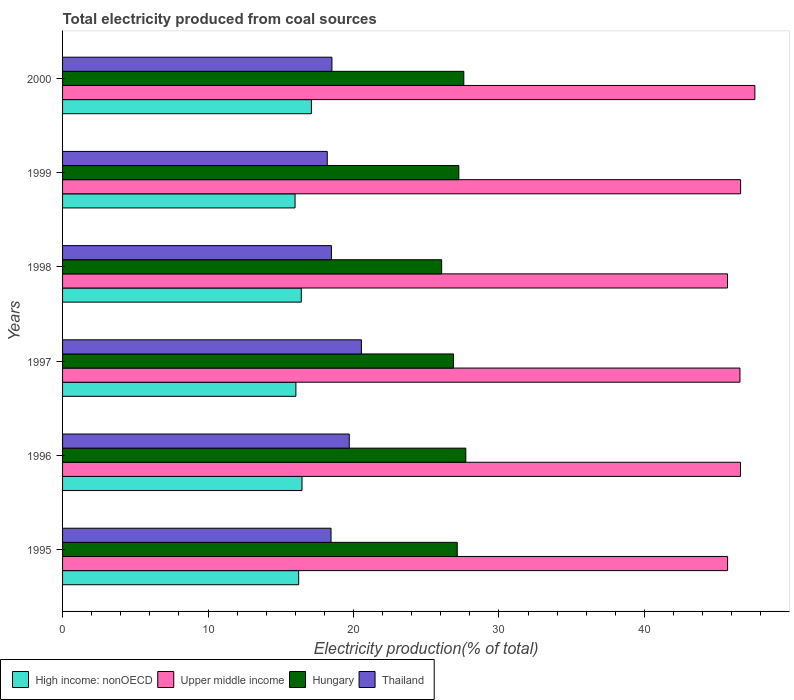How many different coloured bars are there?
Your answer should be very brief. 4. Are the number of bars per tick equal to the number of legend labels?
Offer a very short reply. Yes. How many bars are there on the 5th tick from the top?
Make the answer very short. 4. How many bars are there on the 1st tick from the bottom?
Keep it short and to the point. 4. What is the label of the 4th group of bars from the top?
Offer a terse response. 1997. What is the total electricity produced in Upper middle income in 1997?
Offer a very short reply. 46.57. Across all years, what is the maximum total electricity produced in Hungary?
Provide a succinct answer. 27.72. Across all years, what is the minimum total electricity produced in Thailand?
Your response must be concise. 18.2. In which year was the total electricity produced in Upper middle income maximum?
Ensure brevity in your answer.  2000. What is the total total electricity produced in Upper middle income in the graph?
Offer a terse response. 278.8. What is the difference between the total electricity produced in Thailand in 1996 and that in 1998?
Provide a succinct answer. 1.23. What is the difference between the total electricity produced in Thailand in 1996 and the total electricity produced in Hungary in 1995?
Ensure brevity in your answer.  -7.42. What is the average total electricity produced in Hungary per year?
Make the answer very short. 27.1. In the year 1999, what is the difference between the total electricity produced in Hungary and total electricity produced in Thailand?
Make the answer very short. 9.04. In how many years, is the total electricity produced in Upper middle income greater than 26 %?
Provide a succinct answer. 6. What is the ratio of the total electricity produced in Thailand in 1998 to that in 1999?
Keep it short and to the point. 1.02. Is the total electricity produced in Thailand in 1995 less than that in 2000?
Offer a terse response. Yes. Is the difference between the total electricity produced in Hungary in 1995 and 1998 greater than the difference between the total electricity produced in Thailand in 1995 and 1998?
Keep it short and to the point. Yes. What is the difference between the highest and the second highest total electricity produced in Thailand?
Offer a very short reply. 0.83. What is the difference between the highest and the lowest total electricity produced in High income: nonOECD?
Ensure brevity in your answer.  1.12. Is the sum of the total electricity produced in Hungary in 1997 and 1999 greater than the maximum total electricity produced in Thailand across all years?
Your response must be concise. Yes. Is it the case that in every year, the sum of the total electricity produced in High income: nonOECD and total electricity produced in Upper middle income is greater than the sum of total electricity produced in Hungary and total electricity produced in Thailand?
Your answer should be compact. Yes. What does the 1st bar from the top in 1999 represents?
Ensure brevity in your answer.  Thailand. What does the 4th bar from the bottom in 1997 represents?
Provide a succinct answer. Thailand. How many bars are there?
Offer a very short reply. 24. How many years are there in the graph?
Provide a succinct answer. 6. How many legend labels are there?
Your response must be concise. 4. How are the legend labels stacked?
Your answer should be very brief. Horizontal. What is the title of the graph?
Provide a short and direct response. Total electricity produced from coal sources. Does "Ireland" appear as one of the legend labels in the graph?
Provide a succinct answer. No. What is the Electricity production(% of total) in High income: nonOECD in 1995?
Your answer should be very brief. 16.23. What is the Electricity production(% of total) of Upper middle income in 1995?
Make the answer very short. 45.72. What is the Electricity production(% of total) of Hungary in 1995?
Your answer should be compact. 27.13. What is the Electricity production(% of total) in Thailand in 1995?
Ensure brevity in your answer.  18.46. What is the Electricity production(% of total) in High income: nonOECD in 1996?
Provide a succinct answer. 16.46. What is the Electricity production(% of total) of Upper middle income in 1996?
Give a very brief answer. 46.6. What is the Electricity production(% of total) of Hungary in 1996?
Give a very brief answer. 27.72. What is the Electricity production(% of total) of Thailand in 1996?
Make the answer very short. 19.71. What is the Electricity production(% of total) in High income: nonOECD in 1997?
Offer a very short reply. 16.04. What is the Electricity production(% of total) in Upper middle income in 1997?
Provide a succinct answer. 46.57. What is the Electricity production(% of total) in Hungary in 1997?
Your answer should be very brief. 26.87. What is the Electricity production(% of total) in Thailand in 1997?
Ensure brevity in your answer.  20.54. What is the Electricity production(% of total) in High income: nonOECD in 1998?
Provide a succinct answer. 16.41. What is the Electricity production(% of total) of Upper middle income in 1998?
Your response must be concise. 45.71. What is the Electricity production(% of total) in Hungary in 1998?
Provide a short and direct response. 26.06. What is the Electricity production(% of total) of Thailand in 1998?
Provide a short and direct response. 18.48. What is the Electricity production(% of total) in High income: nonOECD in 1999?
Make the answer very short. 15.98. What is the Electricity production(% of total) in Upper middle income in 1999?
Provide a succinct answer. 46.61. What is the Electricity production(% of total) of Hungary in 1999?
Provide a short and direct response. 27.24. What is the Electricity production(% of total) in Thailand in 1999?
Provide a succinct answer. 18.2. What is the Electricity production(% of total) in High income: nonOECD in 2000?
Keep it short and to the point. 17.11. What is the Electricity production(% of total) in Upper middle income in 2000?
Make the answer very short. 47.59. What is the Electricity production(% of total) in Hungary in 2000?
Ensure brevity in your answer.  27.58. What is the Electricity production(% of total) of Thailand in 2000?
Your answer should be very brief. 18.52. Across all years, what is the maximum Electricity production(% of total) of High income: nonOECD?
Provide a short and direct response. 17.11. Across all years, what is the maximum Electricity production(% of total) in Upper middle income?
Offer a terse response. 47.59. Across all years, what is the maximum Electricity production(% of total) in Hungary?
Provide a succinct answer. 27.72. Across all years, what is the maximum Electricity production(% of total) of Thailand?
Provide a succinct answer. 20.54. Across all years, what is the minimum Electricity production(% of total) in High income: nonOECD?
Ensure brevity in your answer.  15.98. Across all years, what is the minimum Electricity production(% of total) of Upper middle income?
Give a very brief answer. 45.71. Across all years, what is the minimum Electricity production(% of total) of Hungary?
Offer a terse response. 26.06. Across all years, what is the minimum Electricity production(% of total) in Thailand?
Your answer should be compact. 18.2. What is the total Electricity production(% of total) of High income: nonOECD in the graph?
Offer a very short reply. 98.23. What is the total Electricity production(% of total) in Upper middle income in the graph?
Keep it short and to the point. 278.8. What is the total Electricity production(% of total) in Hungary in the graph?
Offer a terse response. 162.61. What is the total Electricity production(% of total) in Thailand in the graph?
Make the answer very short. 113.91. What is the difference between the Electricity production(% of total) in High income: nonOECD in 1995 and that in 1996?
Your answer should be compact. -0.23. What is the difference between the Electricity production(% of total) in Upper middle income in 1995 and that in 1996?
Offer a very short reply. -0.89. What is the difference between the Electricity production(% of total) of Hungary in 1995 and that in 1996?
Your response must be concise. -0.59. What is the difference between the Electricity production(% of total) in Thailand in 1995 and that in 1996?
Ensure brevity in your answer.  -1.25. What is the difference between the Electricity production(% of total) in High income: nonOECD in 1995 and that in 1997?
Give a very brief answer. 0.19. What is the difference between the Electricity production(% of total) in Upper middle income in 1995 and that in 1997?
Provide a short and direct response. -0.85. What is the difference between the Electricity production(% of total) of Hungary in 1995 and that in 1997?
Provide a succinct answer. 0.26. What is the difference between the Electricity production(% of total) in Thailand in 1995 and that in 1997?
Your answer should be compact. -2.09. What is the difference between the Electricity production(% of total) of High income: nonOECD in 1995 and that in 1998?
Offer a very short reply. -0.18. What is the difference between the Electricity production(% of total) in Upper middle income in 1995 and that in 1998?
Offer a very short reply. 0.01. What is the difference between the Electricity production(% of total) of Hungary in 1995 and that in 1998?
Give a very brief answer. 1.07. What is the difference between the Electricity production(% of total) of Thailand in 1995 and that in 1998?
Offer a very short reply. -0.03. What is the difference between the Electricity production(% of total) in High income: nonOECD in 1995 and that in 1999?
Provide a short and direct response. 0.25. What is the difference between the Electricity production(% of total) of Upper middle income in 1995 and that in 1999?
Make the answer very short. -0.89. What is the difference between the Electricity production(% of total) of Hungary in 1995 and that in 1999?
Give a very brief answer. -0.11. What is the difference between the Electricity production(% of total) in Thailand in 1995 and that in 1999?
Provide a short and direct response. 0.26. What is the difference between the Electricity production(% of total) in High income: nonOECD in 1995 and that in 2000?
Provide a short and direct response. -0.87. What is the difference between the Electricity production(% of total) in Upper middle income in 1995 and that in 2000?
Your answer should be compact. -1.88. What is the difference between the Electricity production(% of total) in Hungary in 1995 and that in 2000?
Provide a succinct answer. -0.45. What is the difference between the Electricity production(% of total) in Thailand in 1995 and that in 2000?
Provide a short and direct response. -0.06. What is the difference between the Electricity production(% of total) in High income: nonOECD in 1996 and that in 1997?
Make the answer very short. 0.42. What is the difference between the Electricity production(% of total) in Upper middle income in 1996 and that in 1997?
Your answer should be very brief. 0.04. What is the difference between the Electricity production(% of total) of Hungary in 1996 and that in 1997?
Offer a terse response. 0.85. What is the difference between the Electricity production(% of total) of Thailand in 1996 and that in 1997?
Your answer should be very brief. -0.83. What is the difference between the Electricity production(% of total) in High income: nonOECD in 1996 and that in 1998?
Give a very brief answer. 0.05. What is the difference between the Electricity production(% of total) of Upper middle income in 1996 and that in 1998?
Offer a very short reply. 0.89. What is the difference between the Electricity production(% of total) in Hungary in 1996 and that in 1998?
Give a very brief answer. 1.66. What is the difference between the Electricity production(% of total) of Thailand in 1996 and that in 1998?
Give a very brief answer. 1.23. What is the difference between the Electricity production(% of total) of High income: nonOECD in 1996 and that in 1999?
Your answer should be very brief. 0.48. What is the difference between the Electricity production(% of total) in Upper middle income in 1996 and that in 1999?
Your answer should be compact. -0.01. What is the difference between the Electricity production(% of total) in Hungary in 1996 and that in 1999?
Keep it short and to the point. 0.48. What is the difference between the Electricity production(% of total) in Thailand in 1996 and that in 1999?
Make the answer very short. 1.51. What is the difference between the Electricity production(% of total) of High income: nonOECD in 1996 and that in 2000?
Offer a terse response. -0.65. What is the difference between the Electricity production(% of total) of Upper middle income in 1996 and that in 2000?
Give a very brief answer. -0.99. What is the difference between the Electricity production(% of total) of Hungary in 1996 and that in 2000?
Ensure brevity in your answer.  0.14. What is the difference between the Electricity production(% of total) of Thailand in 1996 and that in 2000?
Ensure brevity in your answer.  1.19. What is the difference between the Electricity production(% of total) of High income: nonOECD in 1997 and that in 1998?
Provide a succinct answer. -0.37. What is the difference between the Electricity production(% of total) in Upper middle income in 1997 and that in 1998?
Keep it short and to the point. 0.86. What is the difference between the Electricity production(% of total) of Hungary in 1997 and that in 1998?
Give a very brief answer. 0.81. What is the difference between the Electricity production(% of total) in Thailand in 1997 and that in 1998?
Provide a short and direct response. 2.06. What is the difference between the Electricity production(% of total) of High income: nonOECD in 1997 and that in 1999?
Your answer should be very brief. 0.06. What is the difference between the Electricity production(% of total) of Upper middle income in 1997 and that in 1999?
Offer a terse response. -0.05. What is the difference between the Electricity production(% of total) in Hungary in 1997 and that in 1999?
Provide a succinct answer. -0.37. What is the difference between the Electricity production(% of total) in Thailand in 1997 and that in 1999?
Your answer should be very brief. 2.35. What is the difference between the Electricity production(% of total) in High income: nonOECD in 1997 and that in 2000?
Offer a very short reply. -1.07. What is the difference between the Electricity production(% of total) in Upper middle income in 1997 and that in 2000?
Keep it short and to the point. -1.03. What is the difference between the Electricity production(% of total) in Hungary in 1997 and that in 2000?
Keep it short and to the point. -0.71. What is the difference between the Electricity production(% of total) in Thailand in 1997 and that in 2000?
Your answer should be very brief. 2.03. What is the difference between the Electricity production(% of total) of High income: nonOECD in 1998 and that in 1999?
Make the answer very short. 0.43. What is the difference between the Electricity production(% of total) in Upper middle income in 1998 and that in 1999?
Keep it short and to the point. -0.9. What is the difference between the Electricity production(% of total) of Hungary in 1998 and that in 1999?
Make the answer very short. -1.18. What is the difference between the Electricity production(% of total) in Thailand in 1998 and that in 1999?
Give a very brief answer. 0.29. What is the difference between the Electricity production(% of total) in High income: nonOECD in 1998 and that in 2000?
Offer a terse response. -0.69. What is the difference between the Electricity production(% of total) in Upper middle income in 1998 and that in 2000?
Your answer should be very brief. -1.88. What is the difference between the Electricity production(% of total) in Hungary in 1998 and that in 2000?
Provide a short and direct response. -1.52. What is the difference between the Electricity production(% of total) of Thailand in 1998 and that in 2000?
Your response must be concise. -0.04. What is the difference between the Electricity production(% of total) in High income: nonOECD in 1999 and that in 2000?
Make the answer very short. -1.12. What is the difference between the Electricity production(% of total) of Upper middle income in 1999 and that in 2000?
Provide a succinct answer. -0.98. What is the difference between the Electricity production(% of total) in Hungary in 1999 and that in 2000?
Keep it short and to the point. -0.34. What is the difference between the Electricity production(% of total) of Thailand in 1999 and that in 2000?
Offer a terse response. -0.32. What is the difference between the Electricity production(% of total) in High income: nonOECD in 1995 and the Electricity production(% of total) in Upper middle income in 1996?
Make the answer very short. -30.37. What is the difference between the Electricity production(% of total) of High income: nonOECD in 1995 and the Electricity production(% of total) of Hungary in 1996?
Offer a very short reply. -11.49. What is the difference between the Electricity production(% of total) of High income: nonOECD in 1995 and the Electricity production(% of total) of Thailand in 1996?
Your response must be concise. -3.48. What is the difference between the Electricity production(% of total) of Upper middle income in 1995 and the Electricity production(% of total) of Hungary in 1996?
Ensure brevity in your answer.  18. What is the difference between the Electricity production(% of total) in Upper middle income in 1995 and the Electricity production(% of total) in Thailand in 1996?
Offer a terse response. 26.01. What is the difference between the Electricity production(% of total) in Hungary in 1995 and the Electricity production(% of total) in Thailand in 1996?
Offer a very short reply. 7.42. What is the difference between the Electricity production(% of total) of High income: nonOECD in 1995 and the Electricity production(% of total) of Upper middle income in 1997?
Give a very brief answer. -30.34. What is the difference between the Electricity production(% of total) in High income: nonOECD in 1995 and the Electricity production(% of total) in Hungary in 1997?
Provide a short and direct response. -10.64. What is the difference between the Electricity production(% of total) in High income: nonOECD in 1995 and the Electricity production(% of total) in Thailand in 1997?
Provide a succinct answer. -4.31. What is the difference between the Electricity production(% of total) of Upper middle income in 1995 and the Electricity production(% of total) of Hungary in 1997?
Your answer should be compact. 18.85. What is the difference between the Electricity production(% of total) in Upper middle income in 1995 and the Electricity production(% of total) in Thailand in 1997?
Ensure brevity in your answer.  25.17. What is the difference between the Electricity production(% of total) in Hungary in 1995 and the Electricity production(% of total) in Thailand in 1997?
Offer a terse response. 6.59. What is the difference between the Electricity production(% of total) of High income: nonOECD in 1995 and the Electricity production(% of total) of Upper middle income in 1998?
Ensure brevity in your answer.  -29.48. What is the difference between the Electricity production(% of total) in High income: nonOECD in 1995 and the Electricity production(% of total) in Hungary in 1998?
Ensure brevity in your answer.  -9.83. What is the difference between the Electricity production(% of total) of High income: nonOECD in 1995 and the Electricity production(% of total) of Thailand in 1998?
Keep it short and to the point. -2.25. What is the difference between the Electricity production(% of total) of Upper middle income in 1995 and the Electricity production(% of total) of Hungary in 1998?
Give a very brief answer. 19.66. What is the difference between the Electricity production(% of total) in Upper middle income in 1995 and the Electricity production(% of total) in Thailand in 1998?
Your answer should be very brief. 27.23. What is the difference between the Electricity production(% of total) of Hungary in 1995 and the Electricity production(% of total) of Thailand in 1998?
Give a very brief answer. 8.65. What is the difference between the Electricity production(% of total) in High income: nonOECD in 1995 and the Electricity production(% of total) in Upper middle income in 1999?
Offer a very short reply. -30.38. What is the difference between the Electricity production(% of total) in High income: nonOECD in 1995 and the Electricity production(% of total) in Hungary in 1999?
Provide a succinct answer. -11.01. What is the difference between the Electricity production(% of total) in High income: nonOECD in 1995 and the Electricity production(% of total) in Thailand in 1999?
Your answer should be compact. -1.97. What is the difference between the Electricity production(% of total) in Upper middle income in 1995 and the Electricity production(% of total) in Hungary in 1999?
Provide a succinct answer. 18.48. What is the difference between the Electricity production(% of total) of Upper middle income in 1995 and the Electricity production(% of total) of Thailand in 1999?
Your answer should be compact. 27.52. What is the difference between the Electricity production(% of total) in Hungary in 1995 and the Electricity production(% of total) in Thailand in 1999?
Ensure brevity in your answer.  8.94. What is the difference between the Electricity production(% of total) in High income: nonOECD in 1995 and the Electricity production(% of total) in Upper middle income in 2000?
Provide a short and direct response. -31.36. What is the difference between the Electricity production(% of total) of High income: nonOECD in 1995 and the Electricity production(% of total) of Hungary in 2000?
Offer a very short reply. -11.35. What is the difference between the Electricity production(% of total) of High income: nonOECD in 1995 and the Electricity production(% of total) of Thailand in 2000?
Provide a short and direct response. -2.29. What is the difference between the Electricity production(% of total) of Upper middle income in 1995 and the Electricity production(% of total) of Hungary in 2000?
Provide a short and direct response. 18.13. What is the difference between the Electricity production(% of total) in Upper middle income in 1995 and the Electricity production(% of total) in Thailand in 2000?
Keep it short and to the point. 27.2. What is the difference between the Electricity production(% of total) of Hungary in 1995 and the Electricity production(% of total) of Thailand in 2000?
Keep it short and to the point. 8.61. What is the difference between the Electricity production(% of total) in High income: nonOECD in 1996 and the Electricity production(% of total) in Upper middle income in 1997?
Give a very brief answer. -30.11. What is the difference between the Electricity production(% of total) in High income: nonOECD in 1996 and the Electricity production(% of total) in Hungary in 1997?
Offer a very short reply. -10.41. What is the difference between the Electricity production(% of total) of High income: nonOECD in 1996 and the Electricity production(% of total) of Thailand in 1997?
Give a very brief answer. -4.08. What is the difference between the Electricity production(% of total) of Upper middle income in 1996 and the Electricity production(% of total) of Hungary in 1997?
Make the answer very short. 19.73. What is the difference between the Electricity production(% of total) in Upper middle income in 1996 and the Electricity production(% of total) in Thailand in 1997?
Your answer should be very brief. 26.06. What is the difference between the Electricity production(% of total) in Hungary in 1996 and the Electricity production(% of total) in Thailand in 1997?
Offer a very short reply. 7.18. What is the difference between the Electricity production(% of total) in High income: nonOECD in 1996 and the Electricity production(% of total) in Upper middle income in 1998?
Your answer should be compact. -29.25. What is the difference between the Electricity production(% of total) in High income: nonOECD in 1996 and the Electricity production(% of total) in Hungary in 1998?
Make the answer very short. -9.6. What is the difference between the Electricity production(% of total) of High income: nonOECD in 1996 and the Electricity production(% of total) of Thailand in 1998?
Ensure brevity in your answer.  -2.02. What is the difference between the Electricity production(% of total) of Upper middle income in 1996 and the Electricity production(% of total) of Hungary in 1998?
Keep it short and to the point. 20.54. What is the difference between the Electricity production(% of total) in Upper middle income in 1996 and the Electricity production(% of total) in Thailand in 1998?
Your response must be concise. 28.12. What is the difference between the Electricity production(% of total) in Hungary in 1996 and the Electricity production(% of total) in Thailand in 1998?
Offer a terse response. 9.24. What is the difference between the Electricity production(% of total) in High income: nonOECD in 1996 and the Electricity production(% of total) in Upper middle income in 1999?
Your answer should be very brief. -30.15. What is the difference between the Electricity production(% of total) in High income: nonOECD in 1996 and the Electricity production(% of total) in Hungary in 1999?
Provide a succinct answer. -10.78. What is the difference between the Electricity production(% of total) of High income: nonOECD in 1996 and the Electricity production(% of total) of Thailand in 1999?
Give a very brief answer. -1.74. What is the difference between the Electricity production(% of total) in Upper middle income in 1996 and the Electricity production(% of total) in Hungary in 1999?
Ensure brevity in your answer.  19.36. What is the difference between the Electricity production(% of total) of Upper middle income in 1996 and the Electricity production(% of total) of Thailand in 1999?
Keep it short and to the point. 28.41. What is the difference between the Electricity production(% of total) in Hungary in 1996 and the Electricity production(% of total) in Thailand in 1999?
Provide a short and direct response. 9.52. What is the difference between the Electricity production(% of total) in High income: nonOECD in 1996 and the Electricity production(% of total) in Upper middle income in 2000?
Provide a short and direct response. -31.13. What is the difference between the Electricity production(% of total) in High income: nonOECD in 1996 and the Electricity production(% of total) in Hungary in 2000?
Your answer should be compact. -11.12. What is the difference between the Electricity production(% of total) of High income: nonOECD in 1996 and the Electricity production(% of total) of Thailand in 2000?
Your answer should be compact. -2.06. What is the difference between the Electricity production(% of total) of Upper middle income in 1996 and the Electricity production(% of total) of Hungary in 2000?
Provide a succinct answer. 19.02. What is the difference between the Electricity production(% of total) in Upper middle income in 1996 and the Electricity production(% of total) in Thailand in 2000?
Make the answer very short. 28.08. What is the difference between the Electricity production(% of total) in Hungary in 1996 and the Electricity production(% of total) in Thailand in 2000?
Make the answer very short. 9.2. What is the difference between the Electricity production(% of total) of High income: nonOECD in 1997 and the Electricity production(% of total) of Upper middle income in 1998?
Your answer should be compact. -29.67. What is the difference between the Electricity production(% of total) of High income: nonOECD in 1997 and the Electricity production(% of total) of Hungary in 1998?
Keep it short and to the point. -10.02. What is the difference between the Electricity production(% of total) of High income: nonOECD in 1997 and the Electricity production(% of total) of Thailand in 1998?
Offer a terse response. -2.44. What is the difference between the Electricity production(% of total) in Upper middle income in 1997 and the Electricity production(% of total) in Hungary in 1998?
Your answer should be compact. 20.51. What is the difference between the Electricity production(% of total) in Upper middle income in 1997 and the Electricity production(% of total) in Thailand in 1998?
Your response must be concise. 28.08. What is the difference between the Electricity production(% of total) in Hungary in 1997 and the Electricity production(% of total) in Thailand in 1998?
Your answer should be compact. 8.39. What is the difference between the Electricity production(% of total) of High income: nonOECD in 1997 and the Electricity production(% of total) of Upper middle income in 1999?
Give a very brief answer. -30.57. What is the difference between the Electricity production(% of total) of High income: nonOECD in 1997 and the Electricity production(% of total) of Hungary in 1999?
Keep it short and to the point. -11.2. What is the difference between the Electricity production(% of total) of High income: nonOECD in 1997 and the Electricity production(% of total) of Thailand in 1999?
Ensure brevity in your answer.  -2.16. What is the difference between the Electricity production(% of total) in Upper middle income in 1997 and the Electricity production(% of total) in Hungary in 1999?
Make the answer very short. 19.32. What is the difference between the Electricity production(% of total) of Upper middle income in 1997 and the Electricity production(% of total) of Thailand in 1999?
Provide a succinct answer. 28.37. What is the difference between the Electricity production(% of total) in Hungary in 1997 and the Electricity production(% of total) in Thailand in 1999?
Offer a terse response. 8.68. What is the difference between the Electricity production(% of total) in High income: nonOECD in 1997 and the Electricity production(% of total) in Upper middle income in 2000?
Offer a terse response. -31.55. What is the difference between the Electricity production(% of total) in High income: nonOECD in 1997 and the Electricity production(% of total) in Hungary in 2000?
Ensure brevity in your answer.  -11.54. What is the difference between the Electricity production(% of total) of High income: nonOECD in 1997 and the Electricity production(% of total) of Thailand in 2000?
Ensure brevity in your answer.  -2.48. What is the difference between the Electricity production(% of total) of Upper middle income in 1997 and the Electricity production(% of total) of Hungary in 2000?
Your answer should be compact. 18.98. What is the difference between the Electricity production(% of total) in Upper middle income in 1997 and the Electricity production(% of total) in Thailand in 2000?
Offer a terse response. 28.05. What is the difference between the Electricity production(% of total) in Hungary in 1997 and the Electricity production(% of total) in Thailand in 2000?
Offer a very short reply. 8.35. What is the difference between the Electricity production(% of total) of High income: nonOECD in 1998 and the Electricity production(% of total) of Upper middle income in 1999?
Offer a terse response. -30.2. What is the difference between the Electricity production(% of total) of High income: nonOECD in 1998 and the Electricity production(% of total) of Hungary in 1999?
Your response must be concise. -10.83. What is the difference between the Electricity production(% of total) of High income: nonOECD in 1998 and the Electricity production(% of total) of Thailand in 1999?
Provide a short and direct response. -1.79. What is the difference between the Electricity production(% of total) of Upper middle income in 1998 and the Electricity production(% of total) of Hungary in 1999?
Offer a very short reply. 18.47. What is the difference between the Electricity production(% of total) of Upper middle income in 1998 and the Electricity production(% of total) of Thailand in 1999?
Your answer should be very brief. 27.51. What is the difference between the Electricity production(% of total) of Hungary in 1998 and the Electricity production(% of total) of Thailand in 1999?
Ensure brevity in your answer.  7.86. What is the difference between the Electricity production(% of total) in High income: nonOECD in 1998 and the Electricity production(% of total) in Upper middle income in 2000?
Offer a very short reply. -31.18. What is the difference between the Electricity production(% of total) in High income: nonOECD in 1998 and the Electricity production(% of total) in Hungary in 2000?
Ensure brevity in your answer.  -11.17. What is the difference between the Electricity production(% of total) of High income: nonOECD in 1998 and the Electricity production(% of total) of Thailand in 2000?
Offer a terse response. -2.11. What is the difference between the Electricity production(% of total) in Upper middle income in 1998 and the Electricity production(% of total) in Hungary in 2000?
Your answer should be compact. 18.13. What is the difference between the Electricity production(% of total) in Upper middle income in 1998 and the Electricity production(% of total) in Thailand in 2000?
Keep it short and to the point. 27.19. What is the difference between the Electricity production(% of total) of Hungary in 1998 and the Electricity production(% of total) of Thailand in 2000?
Provide a short and direct response. 7.54. What is the difference between the Electricity production(% of total) in High income: nonOECD in 1999 and the Electricity production(% of total) in Upper middle income in 2000?
Make the answer very short. -31.61. What is the difference between the Electricity production(% of total) of High income: nonOECD in 1999 and the Electricity production(% of total) of Hungary in 2000?
Your answer should be very brief. -11.6. What is the difference between the Electricity production(% of total) of High income: nonOECD in 1999 and the Electricity production(% of total) of Thailand in 2000?
Provide a succinct answer. -2.54. What is the difference between the Electricity production(% of total) in Upper middle income in 1999 and the Electricity production(% of total) in Hungary in 2000?
Provide a short and direct response. 19.03. What is the difference between the Electricity production(% of total) of Upper middle income in 1999 and the Electricity production(% of total) of Thailand in 2000?
Give a very brief answer. 28.09. What is the difference between the Electricity production(% of total) in Hungary in 1999 and the Electricity production(% of total) in Thailand in 2000?
Provide a succinct answer. 8.72. What is the average Electricity production(% of total) in High income: nonOECD per year?
Provide a short and direct response. 16.37. What is the average Electricity production(% of total) in Upper middle income per year?
Provide a succinct answer. 46.47. What is the average Electricity production(% of total) of Hungary per year?
Make the answer very short. 27.1. What is the average Electricity production(% of total) in Thailand per year?
Your response must be concise. 18.98. In the year 1995, what is the difference between the Electricity production(% of total) in High income: nonOECD and Electricity production(% of total) in Upper middle income?
Offer a very short reply. -29.49. In the year 1995, what is the difference between the Electricity production(% of total) of High income: nonOECD and Electricity production(% of total) of Hungary?
Make the answer very short. -10.9. In the year 1995, what is the difference between the Electricity production(% of total) in High income: nonOECD and Electricity production(% of total) in Thailand?
Give a very brief answer. -2.22. In the year 1995, what is the difference between the Electricity production(% of total) of Upper middle income and Electricity production(% of total) of Hungary?
Keep it short and to the point. 18.58. In the year 1995, what is the difference between the Electricity production(% of total) in Upper middle income and Electricity production(% of total) in Thailand?
Your answer should be very brief. 27.26. In the year 1995, what is the difference between the Electricity production(% of total) of Hungary and Electricity production(% of total) of Thailand?
Your response must be concise. 8.68. In the year 1996, what is the difference between the Electricity production(% of total) of High income: nonOECD and Electricity production(% of total) of Upper middle income?
Your answer should be compact. -30.14. In the year 1996, what is the difference between the Electricity production(% of total) in High income: nonOECD and Electricity production(% of total) in Hungary?
Make the answer very short. -11.26. In the year 1996, what is the difference between the Electricity production(% of total) in High income: nonOECD and Electricity production(% of total) in Thailand?
Offer a very short reply. -3.25. In the year 1996, what is the difference between the Electricity production(% of total) of Upper middle income and Electricity production(% of total) of Hungary?
Provide a short and direct response. 18.88. In the year 1996, what is the difference between the Electricity production(% of total) in Upper middle income and Electricity production(% of total) in Thailand?
Provide a short and direct response. 26.89. In the year 1996, what is the difference between the Electricity production(% of total) of Hungary and Electricity production(% of total) of Thailand?
Your answer should be compact. 8.01. In the year 1997, what is the difference between the Electricity production(% of total) in High income: nonOECD and Electricity production(% of total) in Upper middle income?
Your answer should be very brief. -30.53. In the year 1997, what is the difference between the Electricity production(% of total) of High income: nonOECD and Electricity production(% of total) of Hungary?
Your answer should be very brief. -10.83. In the year 1997, what is the difference between the Electricity production(% of total) of High income: nonOECD and Electricity production(% of total) of Thailand?
Give a very brief answer. -4.5. In the year 1997, what is the difference between the Electricity production(% of total) in Upper middle income and Electricity production(% of total) in Hungary?
Offer a very short reply. 19.69. In the year 1997, what is the difference between the Electricity production(% of total) in Upper middle income and Electricity production(% of total) in Thailand?
Provide a short and direct response. 26.02. In the year 1997, what is the difference between the Electricity production(% of total) in Hungary and Electricity production(% of total) in Thailand?
Your answer should be very brief. 6.33. In the year 1998, what is the difference between the Electricity production(% of total) of High income: nonOECD and Electricity production(% of total) of Upper middle income?
Ensure brevity in your answer.  -29.3. In the year 1998, what is the difference between the Electricity production(% of total) of High income: nonOECD and Electricity production(% of total) of Hungary?
Provide a succinct answer. -9.65. In the year 1998, what is the difference between the Electricity production(% of total) in High income: nonOECD and Electricity production(% of total) in Thailand?
Offer a terse response. -2.07. In the year 1998, what is the difference between the Electricity production(% of total) of Upper middle income and Electricity production(% of total) of Hungary?
Provide a succinct answer. 19.65. In the year 1998, what is the difference between the Electricity production(% of total) of Upper middle income and Electricity production(% of total) of Thailand?
Your answer should be very brief. 27.23. In the year 1998, what is the difference between the Electricity production(% of total) of Hungary and Electricity production(% of total) of Thailand?
Offer a terse response. 7.58. In the year 1999, what is the difference between the Electricity production(% of total) in High income: nonOECD and Electricity production(% of total) in Upper middle income?
Keep it short and to the point. -30.63. In the year 1999, what is the difference between the Electricity production(% of total) of High income: nonOECD and Electricity production(% of total) of Hungary?
Provide a succinct answer. -11.26. In the year 1999, what is the difference between the Electricity production(% of total) of High income: nonOECD and Electricity production(% of total) of Thailand?
Keep it short and to the point. -2.21. In the year 1999, what is the difference between the Electricity production(% of total) of Upper middle income and Electricity production(% of total) of Hungary?
Offer a terse response. 19.37. In the year 1999, what is the difference between the Electricity production(% of total) of Upper middle income and Electricity production(% of total) of Thailand?
Offer a very short reply. 28.42. In the year 1999, what is the difference between the Electricity production(% of total) of Hungary and Electricity production(% of total) of Thailand?
Keep it short and to the point. 9.04. In the year 2000, what is the difference between the Electricity production(% of total) of High income: nonOECD and Electricity production(% of total) of Upper middle income?
Keep it short and to the point. -30.49. In the year 2000, what is the difference between the Electricity production(% of total) of High income: nonOECD and Electricity production(% of total) of Hungary?
Your answer should be compact. -10.48. In the year 2000, what is the difference between the Electricity production(% of total) of High income: nonOECD and Electricity production(% of total) of Thailand?
Your response must be concise. -1.41. In the year 2000, what is the difference between the Electricity production(% of total) in Upper middle income and Electricity production(% of total) in Hungary?
Provide a short and direct response. 20.01. In the year 2000, what is the difference between the Electricity production(% of total) in Upper middle income and Electricity production(% of total) in Thailand?
Keep it short and to the point. 29.07. In the year 2000, what is the difference between the Electricity production(% of total) in Hungary and Electricity production(% of total) in Thailand?
Your answer should be compact. 9.07. What is the ratio of the Electricity production(% of total) in High income: nonOECD in 1995 to that in 1996?
Offer a very short reply. 0.99. What is the ratio of the Electricity production(% of total) of Hungary in 1995 to that in 1996?
Ensure brevity in your answer.  0.98. What is the ratio of the Electricity production(% of total) in Thailand in 1995 to that in 1996?
Your answer should be very brief. 0.94. What is the ratio of the Electricity production(% of total) in High income: nonOECD in 1995 to that in 1997?
Give a very brief answer. 1.01. What is the ratio of the Electricity production(% of total) of Upper middle income in 1995 to that in 1997?
Your answer should be compact. 0.98. What is the ratio of the Electricity production(% of total) of Hungary in 1995 to that in 1997?
Your answer should be very brief. 1.01. What is the ratio of the Electricity production(% of total) in Thailand in 1995 to that in 1997?
Give a very brief answer. 0.9. What is the ratio of the Electricity production(% of total) of Upper middle income in 1995 to that in 1998?
Your response must be concise. 1. What is the ratio of the Electricity production(% of total) in Hungary in 1995 to that in 1998?
Your answer should be very brief. 1.04. What is the ratio of the Electricity production(% of total) of Thailand in 1995 to that in 1998?
Provide a succinct answer. 1. What is the ratio of the Electricity production(% of total) of High income: nonOECD in 1995 to that in 1999?
Keep it short and to the point. 1.02. What is the ratio of the Electricity production(% of total) of Upper middle income in 1995 to that in 1999?
Offer a terse response. 0.98. What is the ratio of the Electricity production(% of total) in Thailand in 1995 to that in 1999?
Your answer should be compact. 1.01. What is the ratio of the Electricity production(% of total) of High income: nonOECD in 1995 to that in 2000?
Make the answer very short. 0.95. What is the ratio of the Electricity production(% of total) of Upper middle income in 1995 to that in 2000?
Give a very brief answer. 0.96. What is the ratio of the Electricity production(% of total) of Hungary in 1995 to that in 2000?
Make the answer very short. 0.98. What is the ratio of the Electricity production(% of total) of Thailand in 1995 to that in 2000?
Your answer should be very brief. 1. What is the ratio of the Electricity production(% of total) of High income: nonOECD in 1996 to that in 1997?
Make the answer very short. 1.03. What is the ratio of the Electricity production(% of total) in Hungary in 1996 to that in 1997?
Your answer should be compact. 1.03. What is the ratio of the Electricity production(% of total) of Thailand in 1996 to that in 1997?
Ensure brevity in your answer.  0.96. What is the ratio of the Electricity production(% of total) of High income: nonOECD in 1996 to that in 1998?
Offer a terse response. 1. What is the ratio of the Electricity production(% of total) of Upper middle income in 1996 to that in 1998?
Ensure brevity in your answer.  1.02. What is the ratio of the Electricity production(% of total) of Hungary in 1996 to that in 1998?
Your answer should be compact. 1.06. What is the ratio of the Electricity production(% of total) of Thailand in 1996 to that in 1998?
Offer a terse response. 1.07. What is the ratio of the Electricity production(% of total) in High income: nonOECD in 1996 to that in 1999?
Ensure brevity in your answer.  1.03. What is the ratio of the Electricity production(% of total) in Hungary in 1996 to that in 1999?
Your answer should be compact. 1.02. What is the ratio of the Electricity production(% of total) in Thailand in 1996 to that in 1999?
Give a very brief answer. 1.08. What is the ratio of the Electricity production(% of total) in High income: nonOECD in 1996 to that in 2000?
Offer a terse response. 0.96. What is the ratio of the Electricity production(% of total) in Upper middle income in 1996 to that in 2000?
Make the answer very short. 0.98. What is the ratio of the Electricity production(% of total) of Thailand in 1996 to that in 2000?
Your answer should be very brief. 1.06. What is the ratio of the Electricity production(% of total) in High income: nonOECD in 1997 to that in 1998?
Offer a terse response. 0.98. What is the ratio of the Electricity production(% of total) in Upper middle income in 1997 to that in 1998?
Your answer should be very brief. 1.02. What is the ratio of the Electricity production(% of total) of Hungary in 1997 to that in 1998?
Offer a very short reply. 1.03. What is the ratio of the Electricity production(% of total) of Thailand in 1997 to that in 1998?
Make the answer very short. 1.11. What is the ratio of the Electricity production(% of total) in Upper middle income in 1997 to that in 1999?
Provide a succinct answer. 1. What is the ratio of the Electricity production(% of total) of Hungary in 1997 to that in 1999?
Keep it short and to the point. 0.99. What is the ratio of the Electricity production(% of total) of Thailand in 1997 to that in 1999?
Provide a short and direct response. 1.13. What is the ratio of the Electricity production(% of total) in High income: nonOECD in 1997 to that in 2000?
Keep it short and to the point. 0.94. What is the ratio of the Electricity production(% of total) in Upper middle income in 1997 to that in 2000?
Provide a succinct answer. 0.98. What is the ratio of the Electricity production(% of total) in Hungary in 1997 to that in 2000?
Make the answer very short. 0.97. What is the ratio of the Electricity production(% of total) in Thailand in 1997 to that in 2000?
Your answer should be compact. 1.11. What is the ratio of the Electricity production(% of total) in High income: nonOECD in 1998 to that in 1999?
Your answer should be very brief. 1.03. What is the ratio of the Electricity production(% of total) in Upper middle income in 1998 to that in 1999?
Keep it short and to the point. 0.98. What is the ratio of the Electricity production(% of total) in Hungary in 1998 to that in 1999?
Your answer should be compact. 0.96. What is the ratio of the Electricity production(% of total) of Thailand in 1998 to that in 1999?
Your response must be concise. 1.02. What is the ratio of the Electricity production(% of total) of High income: nonOECD in 1998 to that in 2000?
Your answer should be compact. 0.96. What is the ratio of the Electricity production(% of total) of Upper middle income in 1998 to that in 2000?
Make the answer very short. 0.96. What is the ratio of the Electricity production(% of total) in Hungary in 1998 to that in 2000?
Your response must be concise. 0.94. What is the ratio of the Electricity production(% of total) in High income: nonOECD in 1999 to that in 2000?
Your response must be concise. 0.93. What is the ratio of the Electricity production(% of total) in Upper middle income in 1999 to that in 2000?
Your answer should be compact. 0.98. What is the ratio of the Electricity production(% of total) in Hungary in 1999 to that in 2000?
Keep it short and to the point. 0.99. What is the ratio of the Electricity production(% of total) of Thailand in 1999 to that in 2000?
Offer a terse response. 0.98. What is the difference between the highest and the second highest Electricity production(% of total) of High income: nonOECD?
Keep it short and to the point. 0.65. What is the difference between the highest and the second highest Electricity production(% of total) of Upper middle income?
Keep it short and to the point. 0.98. What is the difference between the highest and the second highest Electricity production(% of total) in Hungary?
Provide a short and direct response. 0.14. What is the difference between the highest and the second highest Electricity production(% of total) in Thailand?
Make the answer very short. 0.83. What is the difference between the highest and the lowest Electricity production(% of total) in High income: nonOECD?
Provide a succinct answer. 1.12. What is the difference between the highest and the lowest Electricity production(% of total) in Upper middle income?
Your answer should be compact. 1.88. What is the difference between the highest and the lowest Electricity production(% of total) in Hungary?
Your answer should be very brief. 1.66. What is the difference between the highest and the lowest Electricity production(% of total) of Thailand?
Your response must be concise. 2.35. 